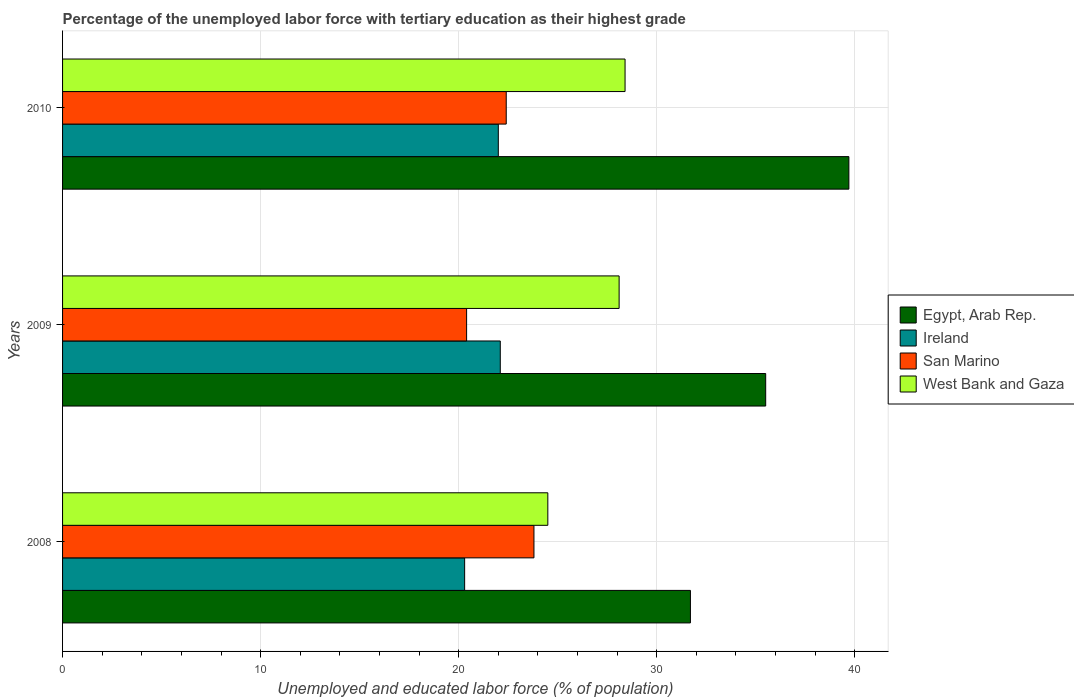How many groups of bars are there?
Give a very brief answer. 3. Are the number of bars on each tick of the Y-axis equal?
Give a very brief answer. Yes. How many bars are there on the 1st tick from the top?
Make the answer very short. 4. What is the label of the 3rd group of bars from the top?
Keep it short and to the point. 2008. In how many cases, is the number of bars for a given year not equal to the number of legend labels?
Provide a short and direct response. 0. What is the percentage of the unemployed labor force with tertiary education in Ireland in 2008?
Your answer should be very brief. 20.3. Across all years, what is the maximum percentage of the unemployed labor force with tertiary education in San Marino?
Ensure brevity in your answer.  23.8. Across all years, what is the minimum percentage of the unemployed labor force with tertiary education in Egypt, Arab Rep.?
Provide a short and direct response. 31.7. In which year was the percentage of the unemployed labor force with tertiary education in Egypt, Arab Rep. maximum?
Ensure brevity in your answer.  2010. In which year was the percentage of the unemployed labor force with tertiary education in Ireland minimum?
Your answer should be very brief. 2008. What is the total percentage of the unemployed labor force with tertiary education in San Marino in the graph?
Ensure brevity in your answer.  66.6. What is the difference between the percentage of the unemployed labor force with tertiary education in West Bank and Gaza in 2009 and that in 2010?
Your answer should be compact. -0.3. What is the difference between the percentage of the unemployed labor force with tertiary education in Ireland in 2010 and the percentage of the unemployed labor force with tertiary education in San Marino in 2009?
Your response must be concise. 1.6. What is the average percentage of the unemployed labor force with tertiary education in Ireland per year?
Offer a very short reply. 21.47. In the year 2008, what is the difference between the percentage of the unemployed labor force with tertiary education in San Marino and percentage of the unemployed labor force with tertiary education in Egypt, Arab Rep.?
Your response must be concise. -7.9. What is the ratio of the percentage of the unemployed labor force with tertiary education in Egypt, Arab Rep. in 2008 to that in 2010?
Give a very brief answer. 0.8. Is the percentage of the unemployed labor force with tertiary education in West Bank and Gaza in 2009 less than that in 2010?
Your response must be concise. Yes. What is the difference between the highest and the second highest percentage of the unemployed labor force with tertiary education in Ireland?
Offer a very short reply. 0.1. What is the difference between the highest and the lowest percentage of the unemployed labor force with tertiary education in West Bank and Gaza?
Keep it short and to the point. 3.9. What does the 3rd bar from the top in 2008 represents?
Give a very brief answer. Ireland. What does the 1st bar from the bottom in 2009 represents?
Your answer should be compact. Egypt, Arab Rep. Is it the case that in every year, the sum of the percentage of the unemployed labor force with tertiary education in San Marino and percentage of the unemployed labor force with tertiary education in Egypt, Arab Rep. is greater than the percentage of the unemployed labor force with tertiary education in West Bank and Gaza?
Offer a terse response. Yes. How many bars are there?
Keep it short and to the point. 12. How many years are there in the graph?
Offer a very short reply. 3. What is the difference between two consecutive major ticks on the X-axis?
Offer a very short reply. 10. Are the values on the major ticks of X-axis written in scientific E-notation?
Keep it short and to the point. No. Does the graph contain grids?
Your answer should be compact. Yes. How are the legend labels stacked?
Your answer should be compact. Vertical. What is the title of the graph?
Keep it short and to the point. Percentage of the unemployed labor force with tertiary education as their highest grade. What is the label or title of the X-axis?
Provide a succinct answer. Unemployed and educated labor force (% of population). What is the label or title of the Y-axis?
Provide a short and direct response. Years. What is the Unemployed and educated labor force (% of population) of Egypt, Arab Rep. in 2008?
Provide a succinct answer. 31.7. What is the Unemployed and educated labor force (% of population) in Ireland in 2008?
Make the answer very short. 20.3. What is the Unemployed and educated labor force (% of population) of San Marino in 2008?
Offer a very short reply. 23.8. What is the Unemployed and educated labor force (% of population) of West Bank and Gaza in 2008?
Your answer should be compact. 24.5. What is the Unemployed and educated labor force (% of population) in Egypt, Arab Rep. in 2009?
Keep it short and to the point. 35.5. What is the Unemployed and educated labor force (% of population) in Ireland in 2009?
Offer a very short reply. 22.1. What is the Unemployed and educated labor force (% of population) in San Marino in 2009?
Your answer should be very brief. 20.4. What is the Unemployed and educated labor force (% of population) of West Bank and Gaza in 2009?
Offer a terse response. 28.1. What is the Unemployed and educated labor force (% of population) in Egypt, Arab Rep. in 2010?
Offer a very short reply. 39.7. What is the Unemployed and educated labor force (% of population) in Ireland in 2010?
Provide a succinct answer. 22. What is the Unemployed and educated labor force (% of population) in San Marino in 2010?
Your response must be concise. 22.4. What is the Unemployed and educated labor force (% of population) in West Bank and Gaza in 2010?
Provide a short and direct response. 28.4. Across all years, what is the maximum Unemployed and educated labor force (% of population) of Egypt, Arab Rep.?
Ensure brevity in your answer.  39.7. Across all years, what is the maximum Unemployed and educated labor force (% of population) of Ireland?
Offer a very short reply. 22.1. Across all years, what is the maximum Unemployed and educated labor force (% of population) of San Marino?
Offer a very short reply. 23.8. Across all years, what is the maximum Unemployed and educated labor force (% of population) of West Bank and Gaza?
Ensure brevity in your answer.  28.4. Across all years, what is the minimum Unemployed and educated labor force (% of population) of Egypt, Arab Rep.?
Your answer should be very brief. 31.7. Across all years, what is the minimum Unemployed and educated labor force (% of population) in Ireland?
Offer a terse response. 20.3. Across all years, what is the minimum Unemployed and educated labor force (% of population) of San Marino?
Your response must be concise. 20.4. What is the total Unemployed and educated labor force (% of population) of Egypt, Arab Rep. in the graph?
Make the answer very short. 106.9. What is the total Unemployed and educated labor force (% of population) of Ireland in the graph?
Provide a short and direct response. 64.4. What is the total Unemployed and educated labor force (% of population) in San Marino in the graph?
Your response must be concise. 66.6. What is the difference between the Unemployed and educated labor force (% of population) in Ireland in 2008 and that in 2010?
Your response must be concise. -1.7. What is the difference between the Unemployed and educated labor force (% of population) in San Marino in 2008 and that in 2010?
Give a very brief answer. 1.4. What is the difference between the Unemployed and educated labor force (% of population) of Egypt, Arab Rep. in 2009 and that in 2010?
Provide a short and direct response. -4.2. What is the difference between the Unemployed and educated labor force (% of population) of Ireland in 2009 and that in 2010?
Provide a succinct answer. 0.1. What is the difference between the Unemployed and educated labor force (% of population) of West Bank and Gaza in 2009 and that in 2010?
Make the answer very short. -0.3. What is the difference between the Unemployed and educated labor force (% of population) of Ireland in 2008 and the Unemployed and educated labor force (% of population) of West Bank and Gaza in 2009?
Offer a very short reply. -7.8. What is the difference between the Unemployed and educated labor force (% of population) of San Marino in 2008 and the Unemployed and educated labor force (% of population) of West Bank and Gaza in 2009?
Offer a very short reply. -4.3. What is the difference between the Unemployed and educated labor force (% of population) of Egypt, Arab Rep. in 2008 and the Unemployed and educated labor force (% of population) of Ireland in 2010?
Provide a succinct answer. 9.7. What is the difference between the Unemployed and educated labor force (% of population) in Egypt, Arab Rep. in 2008 and the Unemployed and educated labor force (% of population) in San Marino in 2010?
Your response must be concise. 9.3. What is the difference between the Unemployed and educated labor force (% of population) in Egypt, Arab Rep. in 2008 and the Unemployed and educated labor force (% of population) in West Bank and Gaza in 2010?
Your answer should be very brief. 3.3. What is the difference between the Unemployed and educated labor force (% of population) of Egypt, Arab Rep. in 2009 and the Unemployed and educated labor force (% of population) of Ireland in 2010?
Offer a very short reply. 13.5. What is the difference between the Unemployed and educated labor force (% of population) of Egypt, Arab Rep. in 2009 and the Unemployed and educated labor force (% of population) of West Bank and Gaza in 2010?
Make the answer very short. 7.1. What is the difference between the Unemployed and educated labor force (% of population) in Ireland in 2009 and the Unemployed and educated labor force (% of population) in San Marino in 2010?
Your answer should be very brief. -0.3. What is the difference between the Unemployed and educated labor force (% of population) of Ireland in 2009 and the Unemployed and educated labor force (% of population) of West Bank and Gaza in 2010?
Ensure brevity in your answer.  -6.3. What is the average Unemployed and educated labor force (% of population) of Egypt, Arab Rep. per year?
Your answer should be very brief. 35.63. What is the average Unemployed and educated labor force (% of population) of Ireland per year?
Offer a terse response. 21.47. What is the average Unemployed and educated labor force (% of population) in San Marino per year?
Provide a succinct answer. 22.2. What is the average Unemployed and educated labor force (% of population) of West Bank and Gaza per year?
Give a very brief answer. 27. In the year 2008, what is the difference between the Unemployed and educated labor force (% of population) of Egypt, Arab Rep. and Unemployed and educated labor force (% of population) of Ireland?
Keep it short and to the point. 11.4. In the year 2008, what is the difference between the Unemployed and educated labor force (% of population) in Egypt, Arab Rep. and Unemployed and educated labor force (% of population) in San Marino?
Your answer should be very brief. 7.9. In the year 2008, what is the difference between the Unemployed and educated labor force (% of population) in Egypt, Arab Rep. and Unemployed and educated labor force (% of population) in West Bank and Gaza?
Offer a very short reply. 7.2. In the year 2008, what is the difference between the Unemployed and educated labor force (% of population) of Ireland and Unemployed and educated labor force (% of population) of San Marino?
Offer a terse response. -3.5. In the year 2008, what is the difference between the Unemployed and educated labor force (% of population) in Ireland and Unemployed and educated labor force (% of population) in West Bank and Gaza?
Give a very brief answer. -4.2. In the year 2008, what is the difference between the Unemployed and educated labor force (% of population) of San Marino and Unemployed and educated labor force (% of population) of West Bank and Gaza?
Offer a very short reply. -0.7. In the year 2009, what is the difference between the Unemployed and educated labor force (% of population) in Ireland and Unemployed and educated labor force (% of population) in West Bank and Gaza?
Provide a succinct answer. -6. In the year 2009, what is the difference between the Unemployed and educated labor force (% of population) of San Marino and Unemployed and educated labor force (% of population) of West Bank and Gaza?
Make the answer very short. -7.7. In the year 2010, what is the difference between the Unemployed and educated labor force (% of population) in Egypt, Arab Rep. and Unemployed and educated labor force (% of population) in San Marino?
Provide a succinct answer. 17.3. In the year 2010, what is the difference between the Unemployed and educated labor force (% of population) of Egypt, Arab Rep. and Unemployed and educated labor force (% of population) of West Bank and Gaza?
Your answer should be compact. 11.3. What is the ratio of the Unemployed and educated labor force (% of population) of Egypt, Arab Rep. in 2008 to that in 2009?
Offer a terse response. 0.89. What is the ratio of the Unemployed and educated labor force (% of population) of Ireland in 2008 to that in 2009?
Keep it short and to the point. 0.92. What is the ratio of the Unemployed and educated labor force (% of population) in West Bank and Gaza in 2008 to that in 2009?
Your response must be concise. 0.87. What is the ratio of the Unemployed and educated labor force (% of population) of Egypt, Arab Rep. in 2008 to that in 2010?
Your answer should be compact. 0.8. What is the ratio of the Unemployed and educated labor force (% of population) of Ireland in 2008 to that in 2010?
Your response must be concise. 0.92. What is the ratio of the Unemployed and educated labor force (% of population) of San Marino in 2008 to that in 2010?
Make the answer very short. 1.06. What is the ratio of the Unemployed and educated labor force (% of population) in West Bank and Gaza in 2008 to that in 2010?
Provide a succinct answer. 0.86. What is the ratio of the Unemployed and educated labor force (% of population) in Egypt, Arab Rep. in 2009 to that in 2010?
Give a very brief answer. 0.89. What is the ratio of the Unemployed and educated labor force (% of population) in San Marino in 2009 to that in 2010?
Offer a terse response. 0.91. What is the difference between the highest and the second highest Unemployed and educated labor force (% of population) of Egypt, Arab Rep.?
Offer a very short reply. 4.2. What is the difference between the highest and the second highest Unemployed and educated labor force (% of population) of West Bank and Gaza?
Your answer should be compact. 0.3. What is the difference between the highest and the lowest Unemployed and educated labor force (% of population) of San Marino?
Provide a short and direct response. 3.4. 